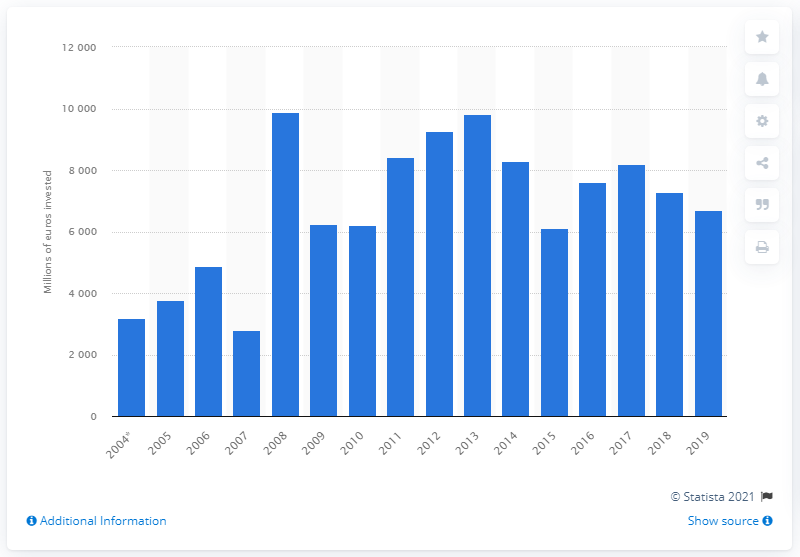Specify some key components in this picture. In 2008, a total of 9,836 was invested in road transport infrastructure in Russia. In 2019, a total of 67,10.81 rubles was invested in road transport infrastructure in Russia. 